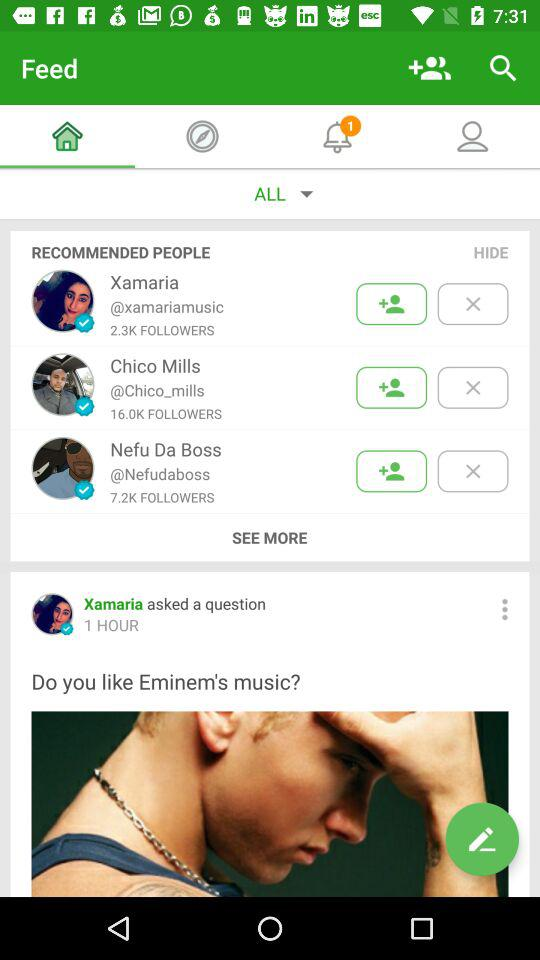How many recommended people are there?
Answer the question using a single word or phrase. 3 